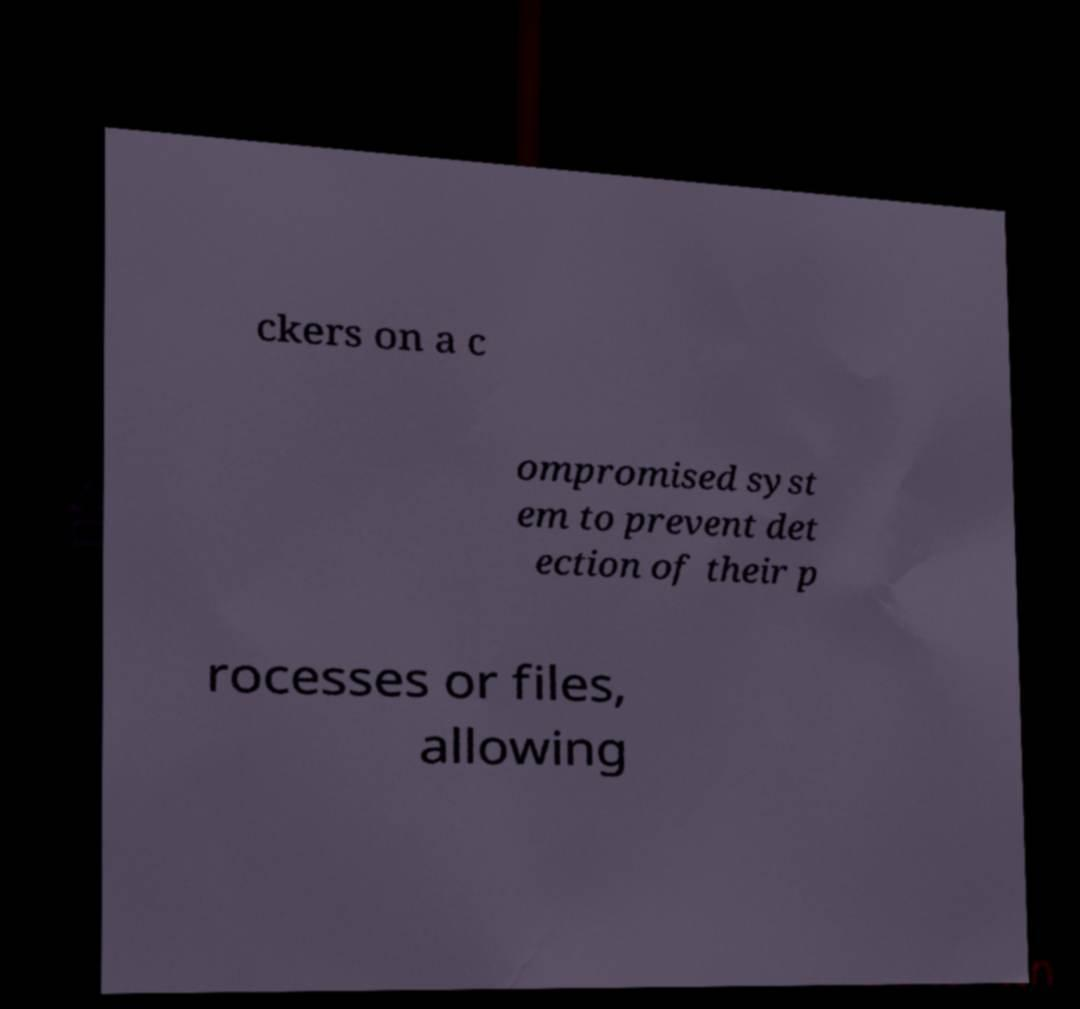I need the written content from this picture converted into text. Can you do that? ckers on a c ompromised syst em to prevent det ection of their p rocesses or files, allowing 